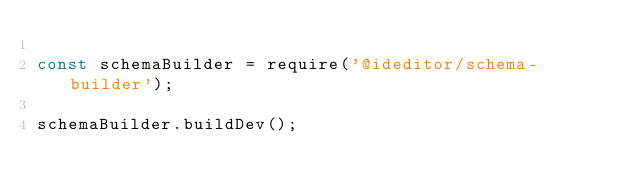Convert code to text. <code><loc_0><loc_0><loc_500><loc_500><_JavaScript_>
const schemaBuilder = require('@ideditor/schema-builder');

schemaBuilder.buildDev();
</code> 